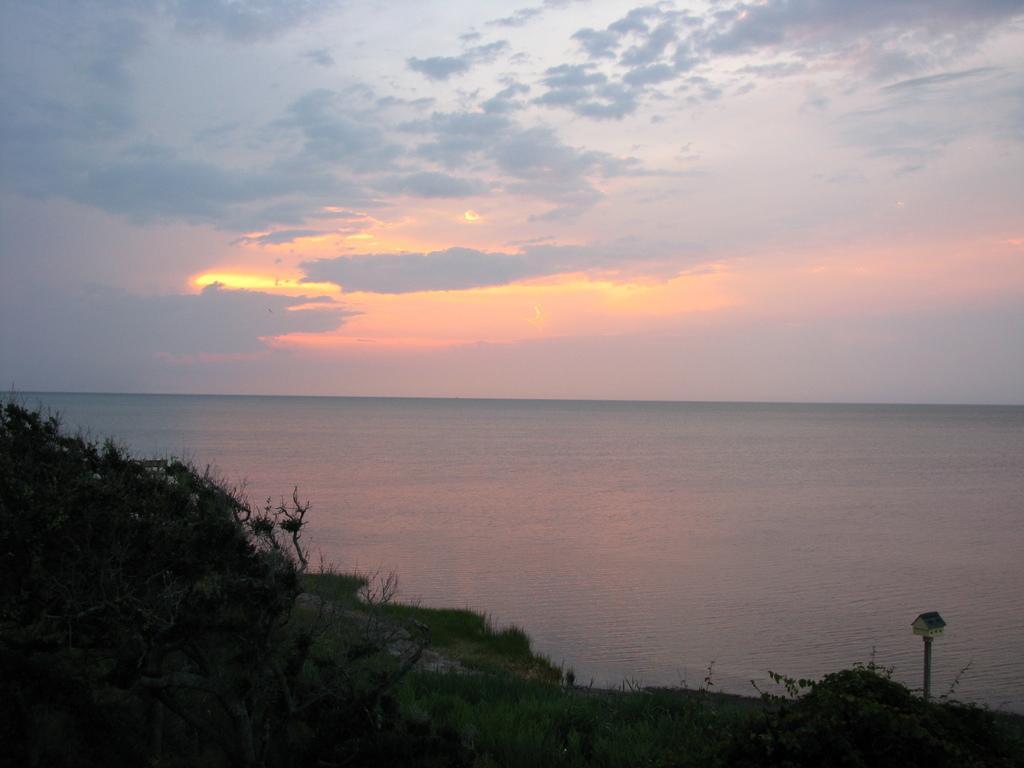In one or two sentences, can you explain what this image depicts? It seems like a scenery in which there is water in the background. At the bottom there is a hill on which there are small plants. At the top there is the sky with the clouds. 